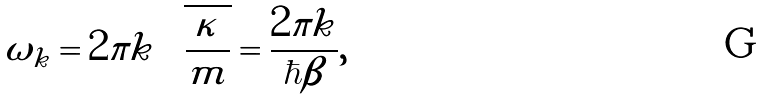<formula> <loc_0><loc_0><loc_500><loc_500>\omega _ { k } = 2 \pi k \sqrt { \frac { \kappa } { m } } = \frac { 2 \pi k } { \hbar { \beta } } ,</formula> 